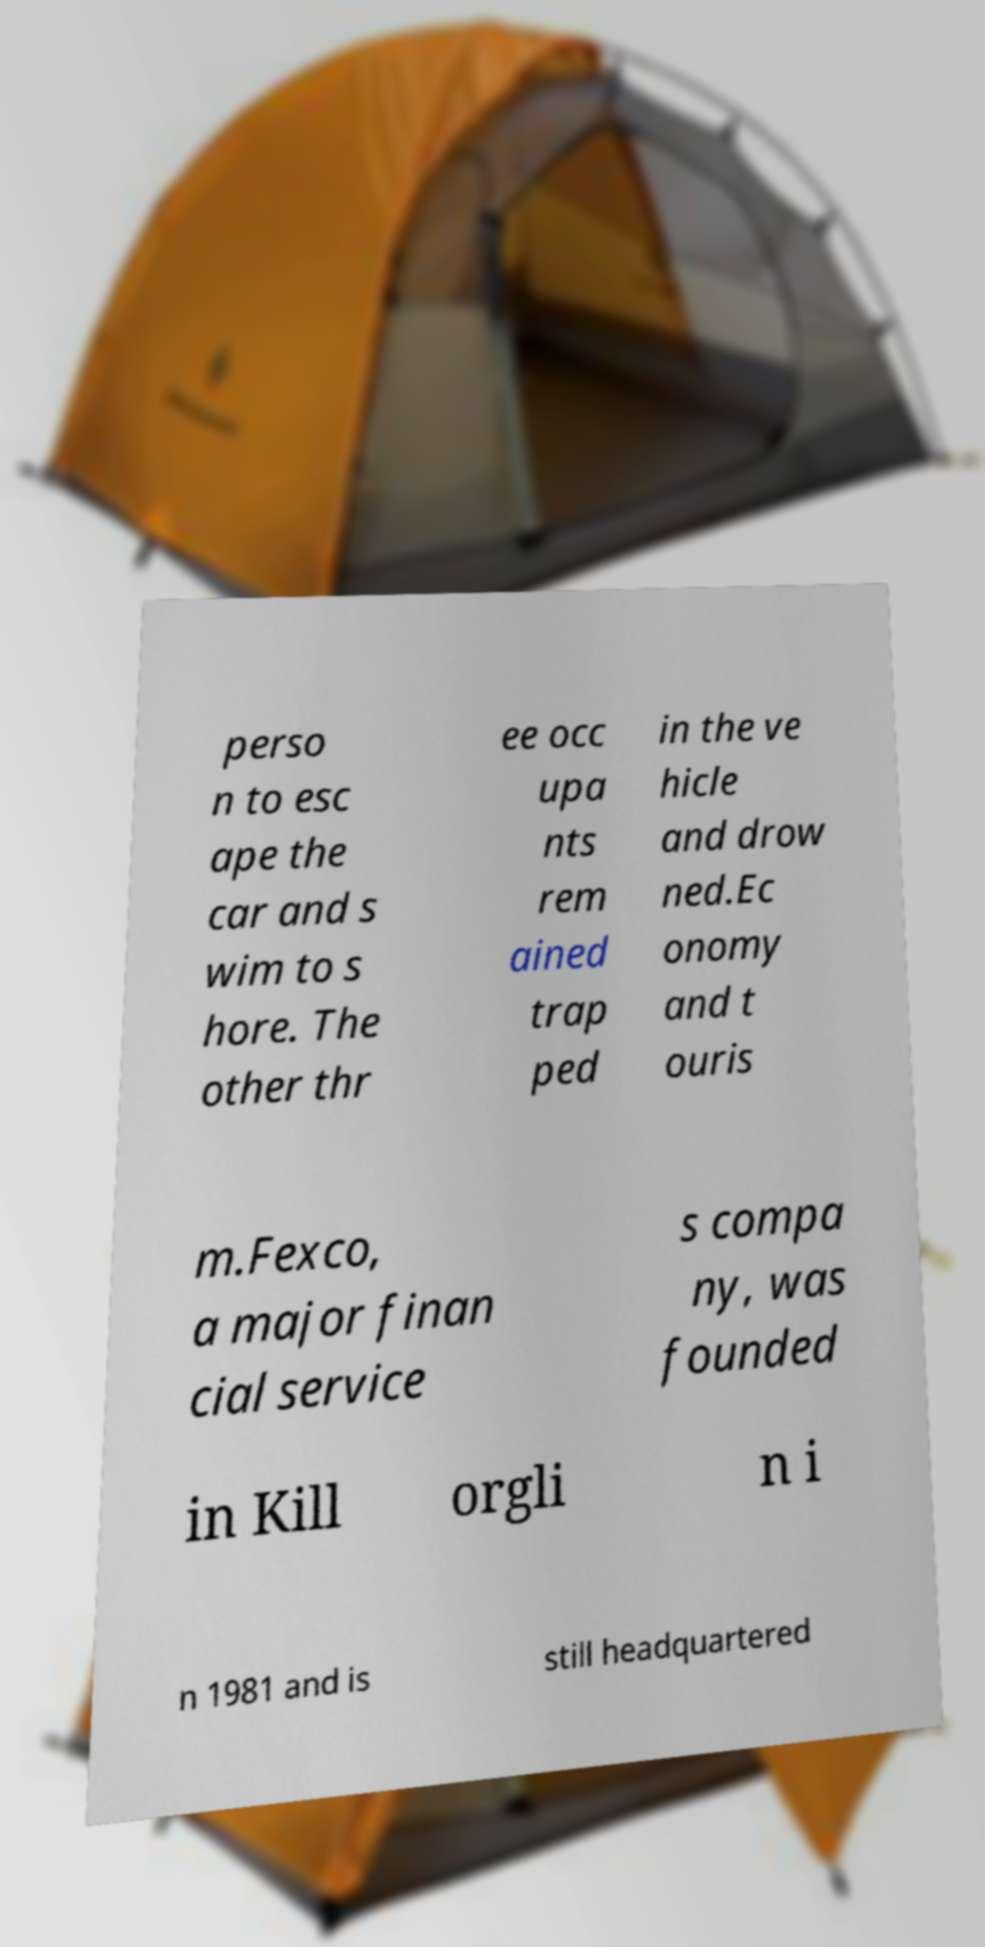Can you accurately transcribe the text from the provided image for me? perso n to esc ape the car and s wim to s hore. The other thr ee occ upa nts rem ained trap ped in the ve hicle and drow ned.Ec onomy and t ouris m.Fexco, a major finan cial service s compa ny, was founded in Kill orgli n i n 1981 and is still headquartered 